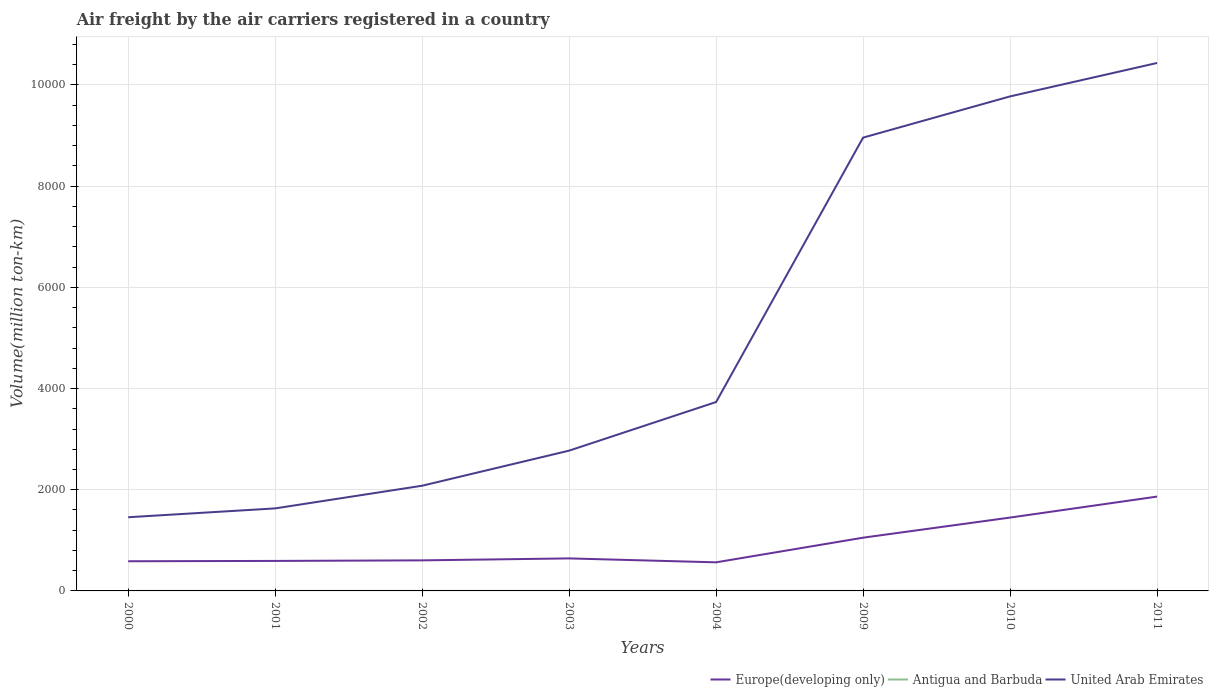How many different coloured lines are there?
Keep it short and to the point. 3. Does the line corresponding to Antigua and Barbuda intersect with the line corresponding to United Arab Emirates?
Keep it short and to the point. No. Across all years, what is the maximum volume of the air carriers in United Arab Emirates?
Ensure brevity in your answer.  1456.35. What is the total volume of the air carriers in Europe(developing only) in the graph?
Make the answer very short. -884.56. What is the difference between the highest and the second highest volume of the air carriers in Antigua and Barbuda?
Make the answer very short. 0.62. What is the difference between the highest and the lowest volume of the air carriers in Antigua and Barbuda?
Give a very brief answer. 2. Does the graph contain any zero values?
Give a very brief answer. No. How many legend labels are there?
Ensure brevity in your answer.  3. What is the title of the graph?
Make the answer very short. Air freight by the air carriers registered in a country. What is the label or title of the Y-axis?
Your answer should be compact. Volume(million ton-km). What is the Volume(million ton-km) in Europe(developing only) in 2000?
Keep it short and to the point. 586.49. What is the Volume(million ton-km) of Antigua and Barbuda in 2000?
Your answer should be compact. 0.21. What is the Volume(million ton-km) of United Arab Emirates in 2000?
Give a very brief answer. 1456.35. What is the Volume(million ton-km) of Europe(developing only) in 2001?
Your response must be concise. 593. What is the Volume(million ton-km) of Antigua and Barbuda in 2001?
Keep it short and to the point. 0.22. What is the Volume(million ton-km) of United Arab Emirates in 2001?
Provide a short and direct response. 1631.16. What is the Volume(million ton-km) of Europe(developing only) in 2002?
Offer a terse response. 604.13. What is the Volume(million ton-km) of Antigua and Barbuda in 2002?
Give a very brief answer. 0.19. What is the Volume(million ton-km) in United Arab Emirates in 2002?
Keep it short and to the point. 2079.34. What is the Volume(million ton-km) in Europe(developing only) in 2003?
Your response must be concise. 642.76. What is the Volume(million ton-km) in Antigua and Barbuda in 2003?
Offer a very short reply. 0.2. What is the Volume(million ton-km) in United Arab Emirates in 2003?
Ensure brevity in your answer.  2772.74. What is the Volume(million ton-km) in Europe(developing only) in 2004?
Offer a very short reply. 565.21. What is the Volume(million ton-km) in Antigua and Barbuda in 2004?
Offer a terse response. 0.2. What is the Volume(million ton-km) in United Arab Emirates in 2004?
Give a very brief answer. 3733.66. What is the Volume(million ton-km) of Europe(developing only) in 2009?
Provide a succinct answer. 1052.31. What is the Volume(million ton-km) of Antigua and Barbuda in 2009?
Give a very brief answer. 0.17. What is the Volume(million ton-km) in United Arab Emirates in 2009?
Ensure brevity in your answer.  8959.6. What is the Volume(million ton-km) of Europe(developing only) in 2010?
Provide a short and direct response. 1449.77. What is the Volume(million ton-km) in Antigua and Barbuda in 2010?
Your answer should be very brief. 0.79. What is the Volume(million ton-km) in United Arab Emirates in 2010?
Your answer should be compact. 9774.15. What is the Volume(million ton-km) of Europe(developing only) in 2011?
Your response must be concise. 1864.46. What is the Volume(million ton-km) of Antigua and Barbuda in 2011?
Your answer should be compact. 0.74. What is the Volume(million ton-km) in United Arab Emirates in 2011?
Keep it short and to the point. 1.04e+04. Across all years, what is the maximum Volume(million ton-km) of Europe(developing only)?
Ensure brevity in your answer.  1864.46. Across all years, what is the maximum Volume(million ton-km) of Antigua and Barbuda?
Offer a very short reply. 0.79. Across all years, what is the maximum Volume(million ton-km) of United Arab Emirates?
Give a very brief answer. 1.04e+04. Across all years, what is the minimum Volume(million ton-km) in Europe(developing only)?
Provide a succinct answer. 565.21. Across all years, what is the minimum Volume(million ton-km) of Antigua and Barbuda?
Make the answer very short. 0.17. Across all years, what is the minimum Volume(million ton-km) in United Arab Emirates?
Ensure brevity in your answer.  1456.35. What is the total Volume(million ton-km) of Europe(developing only) in the graph?
Your response must be concise. 7358.14. What is the total Volume(million ton-km) in Antigua and Barbuda in the graph?
Your answer should be very brief. 2.71. What is the total Volume(million ton-km) of United Arab Emirates in the graph?
Give a very brief answer. 4.08e+04. What is the difference between the Volume(million ton-km) in Europe(developing only) in 2000 and that in 2001?
Give a very brief answer. -6.51. What is the difference between the Volume(million ton-km) in Antigua and Barbuda in 2000 and that in 2001?
Give a very brief answer. -0.01. What is the difference between the Volume(million ton-km) in United Arab Emirates in 2000 and that in 2001?
Provide a short and direct response. -174.81. What is the difference between the Volume(million ton-km) of Europe(developing only) in 2000 and that in 2002?
Your answer should be compact. -17.64. What is the difference between the Volume(million ton-km) in Antigua and Barbuda in 2000 and that in 2002?
Offer a terse response. 0.02. What is the difference between the Volume(million ton-km) in United Arab Emirates in 2000 and that in 2002?
Your answer should be very brief. -622.99. What is the difference between the Volume(million ton-km) in Europe(developing only) in 2000 and that in 2003?
Your response must be concise. -56.27. What is the difference between the Volume(million ton-km) of Antigua and Barbuda in 2000 and that in 2003?
Provide a short and direct response. 0.02. What is the difference between the Volume(million ton-km) of United Arab Emirates in 2000 and that in 2003?
Make the answer very short. -1316.39. What is the difference between the Volume(million ton-km) in Europe(developing only) in 2000 and that in 2004?
Make the answer very short. 21.28. What is the difference between the Volume(million ton-km) in Antigua and Barbuda in 2000 and that in 2004?
Give a very brief answer. 0.02. What is the difference between the Volume(million ton-km) in United Arab Emirates in 2000 and that in 2004?
Give a very brief answer. -2277.31. What is the difference between the Volume(million ton-km) in Europe(developing only) in 2000 and that in 2009?
Give a very brief answer. -465.82. What is the difference between the Volume(million ton-km) in Antigua and Barbuda in 2000 and that in 2009?
Your response must be concise. 0.05. What is the difference between the Volume(million ton-km) of United Arab Emirates in 2000 and that in 2009?
Offer a very short reply. -7503.25. What is the difference between the Volume(million ton-km) of Europe(developing only) in 2000 and that in 2010?
Offer a terse response. -863.28. What is the difference between the Volume(million ton-km) of Antigua and Barbuda in 2000 and that in 2010?
Provide a succinct answer. -0.57. What is the difference between the Volume(million ton-km) of United Arab Emirates in 2000 and that in 2010?
Your answer should be very brief. -8317.8. What is the difference between the Volume(million ton-km) of Europe(developing only) in 2000 and that in 2011?
Keep it short and to the point. -1277.97. What is the difference between the Volume(million ton-km) of Antigua and Barbuda in 2000 and that in 2011?
Make the answer very short. -0.52. What is the difference between the Volume(million ton-km) in United Arab Emirates in 2000 and that in 2011?
Keep it short and to the point. -8978.5. What is the difference between the Volume(million ton-km) of Europe(developing only) in 2001 and that in 2002?
Keep it short and to the point. -11.13. What is the difference between the Volume(million ton-km) of Antigua and Barbuda in 2001 and that in 2002?
Provide a short and direct response. 0.03. What is the difference between the Volume(million ton-km) of United Arab Emirates in 2001 and that in 2002?
Keep it short and to the point. -448.17. What is the difference between the Volume(million ton-km) in Europe(developing only) in 2001 and that in 2003?
Your response must be concise. -49.77. What is the difference between the Volume(million ton-km) of Antigua and Barbuda in 2001 and that in 2003?
Ensure brevity in your answer.  0.03. What is the difference between the Volume(million ton-km) in United Arab Emirates in 2001 and that in 2003?
Your response must be concise. -1141.58. What is the difference between the Volume(million ton-km) of Europe(developing only) in 2001 and that in 2004?
Offer a terse response. 27.78. What is the difference between the Volume(million ton-km) in Antigua and Barbuda in 2001 and that in 2004?
Make the answer very short. 0.03. What is the difference between the Volume(million ton-km) of United Arab Emirates in 2001 and that in 2004?
Ensure brevity in your answer.  -2102.49. What is the difference between the Volume(million ton-km) of Europe(developing only) in 2001 and that in 2009?
Your response must be concise. -459.31. What is the difference between the Volume(million ton-km) in Antigua and Barbuda in 2001 and that in 2009?
Offer a very short reply. 0.06. What is the difference between the Volume(million ton-km) in United Arab Emirates in 2001 and that in 2009?
Your answer should be compact. -7328.44. What is the difference between the Volume(million ton-km) of Europe(developing only) in 2001 and that in 2010?
Keep it short and to the point. -856.78. What is the difference between the Volume(million ton-km) of Antigua and Barbuda in 2001 and that in 2010?
Provide a succinct answer. -0.56. What is the difference between the Volume(million ton-km) of United Arab Emirates in 2001 and that in 2010?
Keep it short and to the point. -8142.99. What is the difference between the Volume(million ton-km) of Europe(developing only) in 2001 and that in 2011?
Your answer should be compact. -1271.46. What is the difference between the Volume(million ton-km) of Antigua and Barbuda in 2001 and that in 2011?
Your answer should be very brief. -0.52. What is the difference between the Volume(million ton-km) in United Arab Emirates in 2001 and that in 2011?
Your answer should be very brief. -8803.69. What is the difference between the Volume(million ton-km) of Europe(developing only) in 2002 and that in 2003?
Your answer should be very brief. -38.63. What is the difference between the Volume(million ton-km) of Antigua and Barbuda in 2002 and that in 2003?
Offer a terse response. -0. What is the difference between the Volume(million ton-km) of United Arab Emirates in 2002 and that in 2003?
Offer a terse response. -693.4. What is the difference between the Volume(million ton-km) in Europe(developing only) in 2002 and that in 2004?
Keep it short and to the point. 38.91. What is the difference between the Volume(million ton-km) in Antigua and Barbuda in 2002 and that in 2004?
Your answer should be very brief. -0. What is the difference between the Volume(million ton-km) of United Arab Emirates in 2002 and that in 2004?
Your answer should be compact. -1654.32. What is the difference between the Volume(million ton-km) of Europe(developing only) in 2002 and that in 2009?
Offer a terse response. -448.18. What is the difference between the Volume(million ton-km) in Antigua and Barbuda in 2002 and that in 2009?
Keep it short and to the point. 0.03. What is the difference between the Volume(million ton-km) in United Arab Emirates in 2002 and that in 2009?
Ensure brevity in your answer.  -6880.26. What is the difference between the Volume(million ton-km) of Europe(developing only) in 2002 and that in 2010?
Make the answer very short. -845.65. What is the difference between the Volume(million ton-km) in Antigua and Barbuda in 2002 and that in 2010?
Provide a succinct answer. -0.59. What is the difference between the Volume(million ton-km) of United Arab Emirates in 2002 and that in 2010?
Offer a terse response. -7694.81. What is the difference between the Volume(million ton-km) in Europe(developing only) in 2002 and that in 2011?
Make the answer very short. -1260.33. What is the difference between the Volume(million ton-km) in Antigua and Barbuda in 2002 and that in 2011?
Your answer should be very brief. -0.54. What is the difference between the Volume(million ton-km) in United Arab Emirates in 2002 and that in 2011?
Offer a terse response. -8355.51. What is the difference between the Volume(million ton-km) of Europe(developing only) in 2003 and that in 2004?
Offer a very short reply. 77.55. What is the difference between the Volume(million ton-km) in Antigua and Barbuda in 2003 and that in 2004?
Your answer should be very brief. 0. What is the difference between the Volume(million ton-km) in United Arab Emirates in 2003 and that in 2004?
Make the answer very short. -960.92. What is the difference between the Volume(million ton-km) of Europe(developing only) in 2003 and that in 2009?
Offer a very short reply. -409.55. What is the difference between the Volume(million ton-km) of Antigua and Barbuda in 2003 and that in 2009?
Offer a very short reply. 0.03. What is the difference between the Volume(million ton-km) in United Arab Emirates in 2003 and that in 2009?
Make the answer very short. -6186.86. What is the difference between the Volume(million ton-km) in Europe(developing only) in 2003 and that in 2010?
Your response must be concise. -807.01. What is the difference between the Volume(million ton-km) of Antigua and Barbuda in 2003 and that in 2010?
Offer a very short reply. -0.59. What is the difference between the Volume(million ton-km) of United Arab Emirates in 2003 and that in 2010?
Give a very brief answer. -7001.41. What is the difference between the Volume(million ton-km) in Europe(developing only) in 2003 and that in 2011?
Give a very brief answer. -1221.69. What is the difference between the Volume(million ton-km) of Antigua and Barbuda in 2003 and that in 2011?
Offer a terse response. -0.54. What is the difference between the Volume(million ton-km) in United Arab Emirates in 2003 and that in 2011?
Offer a terse response. -7662.11. What is the difference between the Volume(million ton-km) of Europe(developing only) in 2004 and that in 2009?
Your answer should be compact. -487.1. What is the difference between the Volume(million ton-km) in Antigua and Barbuda in 2004 and that in 2009?
Make the answer very short. 0.03. What is the difference between the Volume(million ton-km) in United Arab Emirates in 2004 and that in 2009?
Offer a very short reply. -5225.94. What is the difference between the Volume(million ton-km) in Europe(developing only) in 2004 and that in 2010?
Give a very brief answer. -884.56. What is the difference between the Volume(million ton-km) of Antigua and Barbuda in 2004 and that in 2010?
Make the answer very short. -0.59. What is the difference between the Volume(million ton-km) in United Arab Emirates in 2004 and that in 2010?
Give a very brief answer. -6040.49. What is the difference between the Volume(million ton-km) of Europe(developing only) in 2004 and that in 2011?
Your answer should be very brief. -1299.24. What is the difference between the Volume(million ton-km) of Antigua and Barbuda in 2004 and that in 2011?
Give a very brief answer. -0.54. What is the difference between the Volume(million ton-km) in United Arab Emirates in 2004 and that in 2011?
Make the answer very short. -6701.19. What is the difference between the Volume(million ton-km) in Europe(developing only) in 2009 and that in 2010?
Give a very brief answer. -397.46. What is the difference between the Volume(million ton-km) of Antigua and Barbuda in 2009 and that in 2010?
Your response must be concise. -0.62. What is the difference between the Volume(million ton-km) in United Arab Emirates in 2009 and that in 2010?
Make the answer very short. -814.55. What is the difference between the Volume(million ton-km) of Europe(developing only) in 2009 and that in 2011?
Provide a succinct answer. -812.15. What is the difference between the Volume(million ton-km) of Antigua and Barbuda in 2009 and that in 2011?
Provide a short and direct response. -0.57. What is the difference between the Volume(million ton-km) in United Arab Emirates in 2009 and that in 2011?
Your response must be concise. -1475.25. What is the difference between the Volume(million ton-km) in Europe(developing only) in 2010 and that in 2011?
Give a very brief answer. -414.68. What is the difference between the Volume(million ton-km) of Antigua and Barbuda in 2010 and that in 2011?
Your answer should be compact. 0.05. What is the difference between the Volume(million ton-km) of United Arab Emirates in 2010 and that in 2011?
Provide a succinct answer. -660.7. What is the difference between the Volume(million ton-km) of Europe(developing only) in 2000 and the Volume(million ton-km) of Antigua and Barbuda in 2001?
Keep it short and to the point. 586.27. What is the difference between the Volume(million ton-km) in Europe(developing only) in 2000 and the Volume(million ton-km) in United Arab Emirates in 2001?
Provide a short and direct response. -1044.67. What is the difference between the Volume(million ton-km) in Antigua and Barbuda in 2000 and the Volume(million ton-km) in United Arab Emirates in 2001?
Ensure brevity in your answer.  -1630.95. What is the difference between the Volume(million ton-km) of Europe(developing only) in 2000 and the Volume(million ton-km) of Antigua and Barbuda in 2002?
Your answer should be very brief. 586.3. What is the difference between the Volume(million ton-km) in Europe(developing only) in 2000 and the Volume(million ton-km) in United Arab Emirates in 2002?
Make the answer very short. -1492.85. What is the difference between the Volume(million ton-km) in Antigua and Barbuda in 2000 and the Volume(million ton-km) in United Arab Emirates in 2002?
Provide a short and direct response. -2079.12. What is the difference between the Volume(million ton-km) in Europe(developing only) in 2000 and the Volume(million ton-km) in Antigua and Barbuda in 2003?
Offer a very short reply. 586.29. What is the difference between the Volume(million ton-km) of Europe(developing only) in 2000 and the Volume(million ton-km) of United Arab Emirates in 2003?
Provide a short and direct response. -2186.25. What is the difference between the Volume(million ton-km) of Antigua and Barbuda in 2000 and the Volume(million ton-km) of United Arab Emirates in 2003?
Your response must be concise. -2772.52. What is the difference between the Volume(million ton-km) in Europe(developing only) in 2000 and the Volume(million ton-km) in Antigua and Barbuda in 2004?
Offer a very short reply. 586.29. What is the difference between the Volume(million ton-km) in Europe(developing only) in 2000 and the Volume(million ton-km) in United Arab Emirates in 2004?
Keep it short and to the point. -3147.17. What is the difference between the Volume(million ton-km) in Antigua and Barbuda in 2000 and the Volume(million ton-km) in United Arab Emirates in 2004?
Ensure brevity in your answer.  -3733.44. What is the difference between the Volume(million ton-km) of Europe(developing only) in 2000 and the Volume(million ton-km) of Antigua and Barbuda in 2009?
Your answer should be very brief. 586.33. What is the difference between the Volume(million ton-km) in Europe(developing only) in 2000 and the Volume(million ton-km) in United Arab Emirates in 2009?
Your answer should be compact. -8373.11. What is the difference between the Volume(million ton-km) of Antigua and Barbuda in 2000 and the Volume(million ton-km) of United Arab Emirates in 2009?
Give a very brief answer. -8959.39. What is the difference between the Volume(million ton-km) of Europe(developing only) in 2000 and the Volume(million ton-km) of Antigua and Barbuda in 2010?
Make the answer very short. 585.71. What is the difference between the Volume(million ton-km) in Europe(developing only) in 2000 and the Volume(million ton-km) in United Arab Emirates in 2010?
Offer a very short reply. -9187.66. What is the difference between the Volume(million ton-km) in Antigua and Barbuda in 2000 and the Volume(million ton-km) in United Arab Emirates in 2010?
Keep it short and to the point. -9773.94. What is the difference between the Volume(million ton-km) of Europe(developing only) in 2000 and the Volume(million ton-km) of Antigua and Barbuda in 2011?
Ensure brevity in your answer.  585.75. What is the difference between the Volume(million ton-km) of Europe(developing only) in 2000 and the Volume(million ton-km) of United Arab Emirates in 2011?
Provide a succinct answer. -9848.36. What is the difference between the Volume(million ton-km) in Antigua and Barbuda in 2000 and the Volume(million ton-km) in United Arab Emirates in 2011?
Provide a short and direct response. -1.04e+04. What is the difference between the Volume(million ton-km) in Europe(developing only) in 2001 and the Volume(million ton-km) in Antigua and Barbuda in 2002?
Your response must be concise. 592.8. What is the difference between the Volume(million ton-km) of Europe(developing only) in 2001 and the Volume(million ton-km) of United Arab Emirates in 2002?
Give a very brief answer. -1486.34. What is the difference between the Volume(million ton-km) in Antigua and Barbuda in 2001 and the Volume(million ton-km) in United Arab Emirates in 2002?
Make the answer very short. -2079.12. What is the difference between the Volume(million ton-km) of Europe(developing only) in 2001 and the Volume(million ton-km) of Antigua and Barbuda in 2003?
Your answer should be very brief. 592.8. What is the difference between the Volume(million ton-km) in Europe(developing only) in 2001 and the Volume(million ton-km) in United Arab Emirates in 2003?
Provide a succinct answer. -2179.74. What is the difference between the Volume(million ton-km) of Antigua and Barbuda in 2001 and the Volume(million ton-km) of United Arab Emirates in 2003?
Give a very brief answer. -2772.52. What is the difference between the Volume(million ton-km) of Europe(developing only) in 2001 and the Volume(million ton-km) of Antigua and Barbuda in 2004?
Keep it short and to the point. 592.8. What is the difference between the Volume(million ton-km) in Europe(developing only) in 2001 and the Volume(million ton-km) in United Arab Emirates in 2004?
Provide a succinct answer. -3140.66. What is the difference between the Volume(million ton-km) in Antigua and Barbuda in 2001 and the Volume(million ton-km) in United Arab Emirates in 2004?
Offer a very short reply. -3733.44. What is the difference between the Volume(million ton-km) in Europe(developing only) in 2001 and the Volume(million ton-km) in Antigua and Barbuda in 2009?
Your answer should be very brief. 592.83. What is the difference between the Volume(million ton-km) in Europe(developing only) in 2001 and the Volume(million ton-km) in United Arab Emirates in 2009?
Make the answer very short. -8366.6. What is the difference between the Volume(million ton-km) of Antigua and Barbuda in 2001 and the Volume(million ton-km) of United Arab Emirates in 2009?
Your response must be concise. -8959.38. What is the difference between the Volume(million ton-km) in Europe(developing only) in 2001 and the Volume(million ton-km) in Antigua and Barbuda in 2010?
Provide a short and direct response. 592.21. What is the difference between the Volume(million ton-km) of Europe(developing only) in 2001 and the Volume(million ton-km) of United Arab Emirates in 2010?
Your answer should be compact. -9181.15. What is the difference between the Volume(million ton-km) in Antigua and Barbuda in 2001 and the Volume(million ton-km) in United Arab Emirates in 2010?
Your answer should be very brief. -9773.93. What is the difference between the Volume(million ton-km) of Europe(developing only) in 2001 and the Volume(million ton-km) of Antigua and Barbuda in 2011?
Offer a terse response. 592.26. What is the difference between the Volume(million ton-km) in Europe(developing only) in 2001 and the Volume(million ton-km) in United Arab Emirates in 2011?
Ensure brevity in your answer.  -9841.85. What is the difference between the Volume(million ton-km) of Antigua and Barbuda in 2001 and the Volume(million ton-km) of United Arab Emirates in 2011?
Offer a very short reply. -1.04e+04. What is the difference between the Volume(million ton-km) of Europe(developing only) in 2002 and the Volume(million ton-km) of Antigua and Barbuda in 2003?
Your response must be concise. 603.93. What is the difference between the Volume(million ton-km) in Europe(developing only) in 2002 and the Volume(million ton-km) in United Arab Emirates in 2003?
Offer a very short reply. -2168.61. What is the difference between the Volume(million ton-km) of Antigua and Barbuda in 2002 and the Volume(million ton-km) of United Arab Emirates in 2003?
Give a very brief answer. -2772.55. What is the difference between the Volume(million ton-km) of Europe(developing only) in 2002 and the Volume(million ton-km) of Antigua and Barbuda in 2004?
Your response must be concise. 603.93. What is the difference between the Volume(million ton-km) in Europe(developing only) in 2002 and the Volume(million ton-km) in United Arab Emirates in 2004?
Keep it short and to the point. -3129.53. What is the difference between the Volume(million ton-km) in Antigua and Barbuda in 2002 and the Volume(million ton-km) in United Arab Emirates in 2004?
Offer a very short reply. -3733.46. What is the difference between the Volume(million ton-km) of Europe(developing only) in 2002 and the Volume(million ton-km) of Antigua and Barbuda in 2009?
Keep it short and to the point. 603.96. What is the difference between the Volume(million ton-km) in Europe(developing only) in 2002 and the Volume(million ton-km) in United Arab Emirates in 2009?
Ensure brevity in your answer.  -8355.47. What is the difference between the Volume(million ton-km) in Antigua and Barbuda in 2002 and the Volume(million ton-km) in United Arab Emirates in 2009?
Your answer should be very brief. -8959.41. What is the difference between the Volume(million ton-km) of Europe(developing only) in 2002 and the Volume(million ton-km) of Antigua and Barbuda in 2010?
Provide a succinct answer. 603.34. What is the difference between the Volume(million ton-km) in Europe(developing only) in 2002 and the Volume(million ton-km) in United Arab Emirates in 2010?
Your answer should be compact. -9170.02. What is the difference between the Volume(million ton-km) of Antigua and Barbuda in 2002 and the Volume(million ton-km) of United Arab Emirates in 2010?
Your answer should be very brief. -9773.96. What is the difference between the Volume(million ton-km) in Europe(developing only) in 2002 and the Volume(million ton-km) in Antigua and Barbuda in 2011?
Your response must be concise. 603.39. What is the difference between the Volume(million ton-km) of Europe(developing only) in 2002 and the Volume(million ton-km) of United Arab Emirates in 2011?
Offer a very short reply. -9830.72. What is the difference between the Volume(million ton-km) in Antigua and Barbuda in 2002 and the Volume(million ton-km) in United Arab Emirates in 2011?
Keep it short and to the point. -1.04e+04. What is the difference between the Volume(million ton-km) of Europe(developing only) in 2003 and the Volume(million ton-km) of Antigua and Barbuda in 2004?
Provide a succinct answer. 642.57. What is the difference between the Volume(million ton-km) in Europe(developing only) in 2003 and the Volume(million ton-km) in United Arab Emirates in 2004?
Ensure brevity in your answer.  -3090.89. What is the difference between the Volume(million ton-km) in Antigua and Barbuda in 2003 and the Volume(million ton-km) in United Arab Emirates in 2004?
Your response must be concise. -3733.46. What is the difference between the Volume(million ton-km) in Europe(developing only) in 2003 and the Volume(million ton-km) in Antigua and Barbuda in 2009?
Provide a succinct answer. 642.6. What is the difference between the Volume(million ton-km) of Europe(developing only) in 2003 and the Volume(million ton-km) of United Arab Emirates in 2009?
Your answer should be compact. -8316.84. What is the difference between the Volume(million ton-km) in Antigua and Barbuda in 2003 and the Volume(million ton-km) in United Arab Emirates in 2009?
Your answer should be very brief. -8959.41. What is the difference between the Volume(million ton-km) in Europe(developing only) in 2003 and the Volume(million ton-km) in Antigua and Barbuda in 2010?
Provide a short and direct response. 641.98. What is the difference between the Volume(million ton-km) of Europe(developing only) in 2003 and the Volume(million ton-km) of United Arab Emirates in 2010?
Make the answer very short. -9131.39. What is the difference between the Volume(million ton-km) in Antigua and Barbuda in 2003 and the Volume(million ton-km) in United Arab Emirates in 2010?
Provide a succinct answer. -9773.95. What is the difference between the Volume(million ton-km) of Europe(developing only) in 2003 and the Volume(million ton-km) of Antigua and Barbuda in 2011?
Offer a terse response. 642.03. What is the difference between the Volume(million ton-km) of Europe(developing only) in 2003 and the Volume(million ton-km) of United Arab Emirates in 2011?
Provide a short and direct response. -9792.09. What is the difference between the Volume(million ton-km) in Antigua and Barbuda in 2003 and the Volume(million ton-km) in United Arab Emirates in 2011?
Offer a terse response. -1.04e+04. What is the difference between the Volume(million ton-km) in Europe(developing only) in 2004 and the Volume(million ton-km) in Antigua and Barbuda in 2009?
Make the answer very short. 565.05. What is the difference between the Volume(million ton-km) of Europe(developing only) in 2004 and the Volume(million ton-km) of United Arab Emirates in 2009?
Your answer should be very brief. -8394.39. What is the difference between the Volume(million ton-km) of Antigua and Barbuda in 2004 and the Volume(million ton-km) of United Arab Emirates in 2009?
Ensure brevity in your answer.  -8959.41. What is the difference between the Volume(million ton-km) in Europe(developing only) in 2004 and the Volume(million ton-km) in Antigua and Barbuda in 2010?
Provide a succinct answer. 564.43. What is the difference between the Volume(million ton-km) in Europe(developing only) in 2004 and the Volume(million ton-km) in United Arab Emirates in 2010?
Your response must be concise. -9208.94. What is the difference between the Volume(million ton-km) of Antigua and Barbuda in 2004 and the Volume(million ton-km) of United Arab Emirates in 2010?
Your response must be concise. -9773.95. What is the difference between the Volume(million ton-km) in Europe(developing only) in 2004 and the Volume(million ton-km) in Antigua and Barbuda in 2011?
Offer a very short reply. 564.48. What is the difference between the Volume(million ton-km) in Europe(developing only) in 2004 and the Volume(million ton-km) in United Arab Emirates in 2011?
Offer a very short reply. -9869.64. What is the difference between the Volume(million ton-km) in Antigua and Barbuda in 2004 and the Volume(million ton-km) in United Arab Emirates in 2011?
Provide a succinct answer. -1.04e+04. What is the difference between the Volume(million ton-km) of Europe(developing only) in 2009 and the Volume(million ton-km) of Antigua and Barbuda in 2010?
Make the answer very short. 1051.53. What is the difference between the Volume(million ton-km) in Europe(developing only) in 2009 and the Volume(million ton-km) in United Arab Emirates in 2010?
Offer a terse response. -8721.84. What is the difference between the Volume(million ton-km) in Antigua and Barbuda in 2009 and the Volume(million ton-km) in United Arab Emirates in 2010?
Give a very brief answer. -9773.99. What is the difference between the Volume(million ton-km) in Europe(developing only) in 2009 and the Volume(million ton-km) in Antigua and Barbuda in 2011?
Provide a short and direct response. 1051.57. What is the difference between the Volume(million ton-km) of Europe(developing only) in 2009 and the Volume(million ton-km) of United Arab Emirates in 2011?
Give a very brief answer. -9382.54. What is the difference between the Volume(million ton-km) of Antigua and Barbuda in 2009 and the Volume(million ton-km) of United Arab Emirates in 2011?
Your answer should be compact. -1.04e+04. What is the difference between the Volume(million ton-km) in Europe(developing only) in 2010 and the Volume(million ton-km) in Antigua and Barbuda in 2011?
Ensure brevity in your answer.  1449.04. What is the difference between the Volume(million ton-km) of Europe(developing only) in 2010 and the Volume(million ton-km) of United Arab Emirates in 2011?
Ensure brevity in your answer.  -8985.07. What is the difference between the Volume(million ton-km) of Antigua and Barbuda in 2010 and the Volume(million ton-km) of United Arab Emirates in 2011?
Make the answer very short. -1.04e+04. What is the average Volume(million ton-km) of Europe(developing only) per year?
Your response must be concise. 919.77. What is the average Volume(million ton-km) in Antigua and Barbuda per year?
Provide a succinct answer. 0.34. What is the average Volume(million ton-km) of United Arab Emirates per year?
Offer a terse response. 5105.23. In the year 2000, what is the difference between the Volume(million ton-km) in Europe(developing only) and Volume(million ton-km) in Antigua and Barbuda?
Provide a short and direct response. 586.27. In the year 2000, what is the difference between the Volume(million ton-km) of Europe(developing only) and Volume(million ton-km) of United Arab Emirates?
Your response must be concise. -869.86. In the year 2000, what is the difference between the Volume(million ton-km) of Antigua and Barbuda and Volume(million ton-km) of United Arab Emirates?
Make the answer very short. -1456.13. In the year 2001, what is the difference between the Volume(million ton-km) of Europe(developing only) and Volume(million ton-km) of Antigua and Barbuda?
Provide a succinct answer. 592.78. In the year 2001, what is the difference between the Volume(million ton-km) in Europe(developing only) and Volume(million ton-km) in United Arab Emirates?
Keep it short and to the point. -1038.17. In the year 2001, what is the difference between the Volume(million ton-km) in Antigua and Barbuda and Volume(million ton-km) in United Arab Emirates?
Give a very brief answer. -1630.94. In the year 2002, what is the difference between the Volume(million ton-km) of Europe(developing only) and Volume(million ton-km) of Antigua and Barbuda?
Give a very brief answer. 603.93. In the year 2002, what is the difference between the Volume(million ton-km) of Europe(developing only) and Volume(million ton-km) of United Arab Emirates?
Your answer should be very brief. -1475.21. In the year 2002, what is the difference between the Volume(million ton-km) in Antigua and Barbuda and Volume(million ton-km) in United Arab Emirates?
Keep it short and to the point. -2079.14. In the year 2003, what is the difference between the Volume(million ton-km) of Europe(developing only) and Volume(million ton-km) of Antigua and Barbuda?
Provide a succinct answer. 642.57. In the year 2003, what is the difference between the Volume(million ton-km) in Europe(developing only) and Volume(million ton-km) in United Arab Emirates?
Offer a very short reply. -2129.97. In the year 2003, what is the difference between the Volume(million ton-km) of Antigua and Barbuda and Volume(million ton-km) of United Arab Emirates?
Your answer should be very brief. -2772.54. In the year 2004, what is the difference between the Volume(million ton-km) of Europe(developing only) and Volume(million ton-km) of Antigua and Barbuda?
Ensure brevity in your answer.  565.02. In the year 2004, what is the difference between the Volume(million ton-km) of Europe(developing only) and Volume(million ton-km) of United Arab Emirates?
Make the answer very short. -3168.44. In the year 2004, what is the difference between the Volume(million ton-km) of Antigua and Barbuda and Volume(million ton-km) of United Arab Emirates?
Make the answer very short. -3733.46. In the year 2009, what is the difference between the Volume(million ton-km) in Europe(developing only) and Volume(million ton-km) in Antigua and Barbuda?
Keep it short and to the point. 1052.15. In the year 2009, what is the difference between the Volume(million ton-km) in Europe(developing only) and Volume(million ton-km) in United Arab Emirates?
Provide a short and direct response. -7907.29. In the year 2009, what is the difference between the Volume(million ton-km) in Antigua and Barbuda and Volume(million ton-km) in United Arab Emirates?
Keep it short and to the point. -8959.44. In the year 2010, what is the difference between the Volume(million ton-km) of Europe(developing only) and Volume(million ton-km) of Antigua and Barbuda?
Give a very brief answer. 1448.99. In the year 2010, what is the difference between the Volume(million ton-km) in Europe(developing only) and Volume(million ton-km) in United Arab Emirates?
Your answer should be very brief. -8324.38. In the year 2010, what is the difference between the Volume(million ton-km) of Antigua and Barbuda and Volume(million ton-km) of United Arab Emirates?
Make the answer very short. -9773.37. In the year 2011, what is the difference between the Volume(million ton-km) in Europe(developing only) and Volume(million ton-km) in Antigua and Barbuda?
Provide a succinct answer. 1863.72. In the year 2011, what is the difference between the Volume(million ton-km) in Europe(developing only) and Volume(million ton-km) in United Arab Emirates?
Provide a short and direct response. -8570.39. In the year 2011, what is the difference between the Volume(million ton-km) in Antigua and Barbuda and Volume(million ton-km) in United Arab Emirates?
Give a very brief answer. -1.04e+04. What is the ratio of the Volume(million ton-km) of Antigua and Barbuda in 2000 to that in 2001?
Keep it short and to the point. 0.97. What is the ratio of the Volume(million ton-km) in United Arab Emirates in 2000 to that in 2001?
Your response must be concise. 0.89. What is the ratio of the Volume(million ton-km) in Europe(developing only) in 2000 to that in 2002?
Offer a very short reply. 0.97. What is the ratio of the Volume(million ton-km) of Antigua and Barbuda in 2000 to that in 2002?
Your answer should be compact. 1.11. What is the ratio of the Volume(million ton-km) in United Arab Emirates in 2000 to that in 2002?
Offer a very short reply. 0.7. What is the ratio of the Volume(million ton-km) of Europe(developing only) in 2000 to that in 2003?
Ensure brevity in your answer.  0.91. What is the ratio of the Volume(million ton-km) in Antigua and Barbuda in 2000 to that in 2003?
Your response must be concise. 1.1. What is the ratio of the Volume(million ton-km) in United Arab Emirates in 2000 to that in 2003?
Ensure brevity in your answer.  0.53. What is the ratio of the Volume(million ton-km) in Europe(developing only) in 2000 to that in 2004?
Your response must be concise. 1.04. What is the ratio of the Volume(million ton-km) in Antigua and Barbuda in 2000 to that in 2004?
Offer a terse response. 1.1. What is the ratio of the Volume(million ton-km) in United Arab Emirates in 2000 to that in 2004?
Make the answer very short. 0.39. What is the ratio of the Volume(million ton-km) of Europe(developing only) in 2000 to that in 2009?
Offer a very short reply. 0.56. What is the ratio of the Volume(million ton-km) in Antigua and Barbuda in 2000 to that in 2009?
Give a very brief answer. 1.3. What is the ratio of the Volume(million ton-km) in United Arab Emirates in 2000 to that in 2009?
Your answer should be compact. 0.16. What is the ratio of the Volume(million ton-km) of Europe(developing only) in 2000 to that in 2010?
Make the answer very short. 0.4. What is the ratio of the Volume(million ton-km) in Antigua and Barbuda in 2000 to that in 2010?
Give a very brief answer. 0.27. What is the ratio of the Volume(million ton-km) of United Arab Emirates in 2000 to that in 2010?
Offer a very short reply. 0.15. What is the ratio of the Volume(million ton-km) in Europe(developing only) in 2000 to that in 2011?
Provide a short and direct response. 0.31. What is the ratio of the Volume(million ton-km) of Antigua and Barbuda in 2000 to that in 2011?
Offer a very short reply. 0.29. What is the ratio of the Volume(million ton-km) of United Arab Emirates in 2000 to that in 2011?
Offer a terse response. 0.14. What is the ratio of the Volume(million ton-km) in Europe(developing only) in 2001 to that in 2002?
Offer a very short reply. 0.98. What is the ratio of the Volume(million ton-km) in Antigua and Barbuda in 2001 to that in 2002?
Make the answer very short. 1.14. What is the ratio of the Volume(million ton-km) in United Arab Emirates in 2001 to that in 2002?
Your answer should be very brief. 0.78. What is the ratio of the Volume(million ton-km) of Europe(developing only) in 2001 to that in 2003?
Offer a very short reply. 0.92. What is the ratio of the Volume(million ton-km) in Antigua and Barbuda in 2001 to that in 2003?
Your response must be concise. 1.13. What is the ratio of the Volume(million ton-km) in United Arab Emirates in 2001 to that in 2003?
Your answer should be compact. 0.59. What is the ratio of the Volume(million ton-km) of Europe(developing only) in 2001 to that in 2004?
Make the answer very short. 1.05. What is the ratio of the Volume(million ton-km) of Antigua and Barbuda in 2001 to that in 2004?
Your response must be concise. 1.13. What is the ratio of the Volume(million ton-km) in United Arab Emirates in 2001 to that in 2004?
Offer a terse response. 0.44. What is the ratio of the Volume(million ton-km) in Europe(developing only) in 2001 to that in 2009?
Ensure brevity in your answer.  0.56. What is the ratio of the Volume(million ton-km) of Antigua and Barbuda in 2001 to that in 2009?
Make the answer very short. 1.34. What is the ratio of the Volume(million ton-km) in United Arab Emirates in 2001 to that in 2009?
Your response must be concise. 0.18. What is the ratio of the Volume(million ton-km) in Europe(developing only) in 2001 to that in 2010?
Make the answer very short. 0.41. What is the ratio of the Volume(million ton-km) of Antigua and Barbuda in 2001 to that in 2010?
Your response must be concise. 0.28. What is the ratio of the Volume(million ton-km) in United Arab Emirates in 2001 to that in 2010?
Your response must be concise. 0.17. What is the ratio of the Volume(million ton-km) in Europe(developing only) in 2001 to that in 2011?
Your answer should be compact. 0.32. What is the ratio of the Volume(million ton-km) of Antigua and Barbuda in 2001 to that in 2011?
Offer a very short reply. 0.3. What is the ratio of the Volume(million ton-km) of United Arab Emirates in 2001 to that in 2011?
Keep it short and to the point. 0.16. What is the ratio of the Volume(million ton-km) of Europe(developing only) in 2002 to that in 2003?
Offer a very short reply. 0.94. What is the ratio of the Volume(million ton-km) of United Arab Emirates in 2002 to that in 2003?
Give a very brief answer. 0.75. What is the ratio of the Volume(million ton-km) of Europe(developing only) in 2002 to that in 2004?
Keep it short and to the point. 1.07. What is the ratio of the Volume(million ton-km) in United Arab Emirates in 2002 to that in 2004?
Your response must be concise. 0.56. What is the ratio of the Volume(million ton-km) of Europe(developing only) in 2002 to that in 2009?
Give a very brief answer. 0.57. What is the ratio of the Volume(million ton-km) of Antigua and Barbuda in 2002 to that in 2009?
Your answer should be compact. 1.18. What is the ratio of the Volume(million ton-km) of United Arab Emirates in 2002 to that in 2009?
Offer a terse response. 0.23. What is the ratio of the Volume(million ton-km) of Europe(developing only) in 2002 to that in 2010?
Your answer should be very brief. 0.42. What is the ratio of the Volume(million ton-km) of Antigua and Barbuda in 2002 to that in 2010?
Your response must be concise. 0.25. What is the ratio of the Volume(million ton-km) in United Arab Emirates in 2002 to that in 2010?
Offer a very short reply. 0.21. What is the ratio of the Volume(million ton-km) in Europe(developing only) in 2002 to that in 2011?
Offer a very short reply. 0.32. What is the ratio of the Volume(million ton-km) of Antigua and Barbuda in 2002 to that in 2011?
Your answer should be compact. 0.26. What is the ratio of the Volume(million ton-km) of United Arab Emirates in 2002 to that in 2011?
Keep it short and to the point. 0.2. What is the ratio of the Volume(million ton-km) of Europe(developing only) in 2003 to that in 2004?
Your answer should be compact. 1.14. What is the ratio of the Volume(million ton-km) in United Arab Emirates in 2003 to that in 2004?
Offer a terse response. 0.74. What is the ratio of the Volume(million ton-km) in Europe(developing only) in 2003 to that in 2009?
Offer a very short reply. 0.61. What is the ratio of the Volume(million ton-km) in Antigua and Barbuda in 2003 to that in 2009?
Your answer should be compact. 1.19. What is the ratio of the Volume(million ton-km) in United Arab Emirates in 2003 to that in 2009?
Your response must be concise. 0.31. What is the ratio of the Volume(million ton-km) in Europe(developing only) in 2003 to that in 2010?
Give a very brief answer. 0.44. What is the ratio of the Volume(million ton-km) of Antigua and Barbuda in 2003 to that in 2010?
Provide a short and direct response. 0.25. What is the ratio of the Volume(million ton-km) of United Arab Emirates in 2003 to that in 2010?
Your answer should be compact. 0.28. What is the ratio of the Volume(million ton-km) of Europe(developing only) in 2003 to that in 2011?
Provide a succinct answer. 0.34. What is the ratio of the Volume(million ton-km) in Antigua and Barbuda in 2003 to that in 2011?
Your response must be concise. 0.27. What is the ratio of the Volume(million ton-km) of United Arab Emirates in 2003 to that in 2011?
Make the answer very short. 0.27. What is the ratio of the Volume(million ton-km) in Europe(developing only) in 2004 to that in 2009?
Offer a terse response. 0.54. What is the ratio of the Volume(million ton-km) in Antigua and Barbuda in 2004 to that in 2009?
Offer a very short reply. 1.19. What is the ratio of the Volume(million ton-km) in United Arab Emirates in 2004 to that in 2009?
Offer a terse response. 0.42. What is the ratio of the Volume(million ton-km) in Europe(developing only) in 2004 to that in 2010?
Offer a very short reply. 0.39. What is the ratio of the Volume(million ton-km) in Antigua and Barbuda in 2004 to that in 2010?
Your answer should be compact. 0.25. What is the ratio of the Volume(million ton-km) of United Arab Emirates in 2004 to that in 2010?
Provide a short and direct response. 0.38. What is the ratio of the Volume(million ton-km) in Europe(developing only) in 2004 to that in 2011?
Give a very brief answer. 0.3. What is the ratio of the Volume(million ton-km) in Antigua and Barbuda in 2004 to that in 2011?
Your answer should be very brief. 0.27. What is the ratio of the Volume(million ton-km) of United Arab Emirates in 2004 to that in 2011?
Give a very brief answer. 0.36. What is the ratio of the Volume(million ton-km) in Europe(developing only) in 2009 to that in 2010?
Your answer should be compact. 0.73. What is the ratio of the Volume(million ton-km) in Antigua and Barbuda in 2009 to that in 2010?
Make the answer very short. 0.21. What is the ratio of the Volume(million ton-km) in Europe(developing only) in 2009 to that in 2011?
Offer a very short reply. 0.56. What is the ratio of the Volume(million ton-km) in Antigua and Barbuda in 2009 to that in 2011?
Offer a very short reply. 0.22. What is the ratio of the Volume(million ton-km) of United Arab Emirates in 2009 to that in 2011?
Make the answer very short. 0.86. What is the ratio of the Volume(million ton-km) of Europe(developing only) in 2010 to that in 2011?
Provide a succinct answer. 0.78. What is the ratio of the Volume(million ton-km) in Antigua and Barbuda in 2010 to that in 2011?
Your response must be concise. 1.06. What is the ratio of the Volume(million ton-km) in United Arab Emirates in 2010 to that in 2011?
Offer a terse response. 0.94. What is the difference between the highest and the second highest Volume(million ton-km) in Europe(developing only)?
Ensure brevity in your answer.  414.68. What is the difference between the highest and the second highest Volume(million ton-km) in Antigua and Barbuda?
Provide a short and direct response. 0.05. What is the difference between the highest and the second highest Volume(million ton-km) of United Arab Emirates?
Ensure brevity in your answer.  660.7. What is the difference between the highest and the lowest Volume(million ton-km) of Europe(developing only)?
Your answer should be compact. 1299.24. What is the difference between the highest and the lowest Volume(million ton-km) in Antigua and Barbuda?
Make the answer very short. 0.62. What is the difference between the highest and the lowest Volume(million ton-km) of United Arab Emirates?
Provide a succinct answer. 8978.5. 